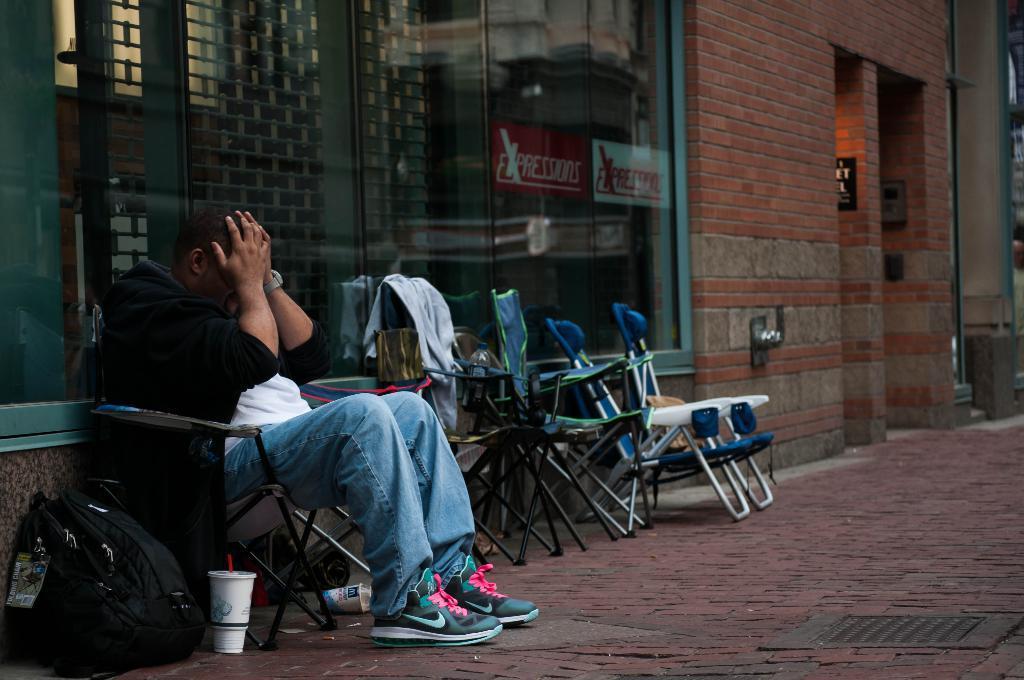In one or two sentences, can you explain what this image depicts? In this image we can see many chairs and we can see a person sitting on a chair. Behind the chairs we can see a glass and a wall. In the bottom left we can see a bag on the surface. On the glass we can see posters with text. 